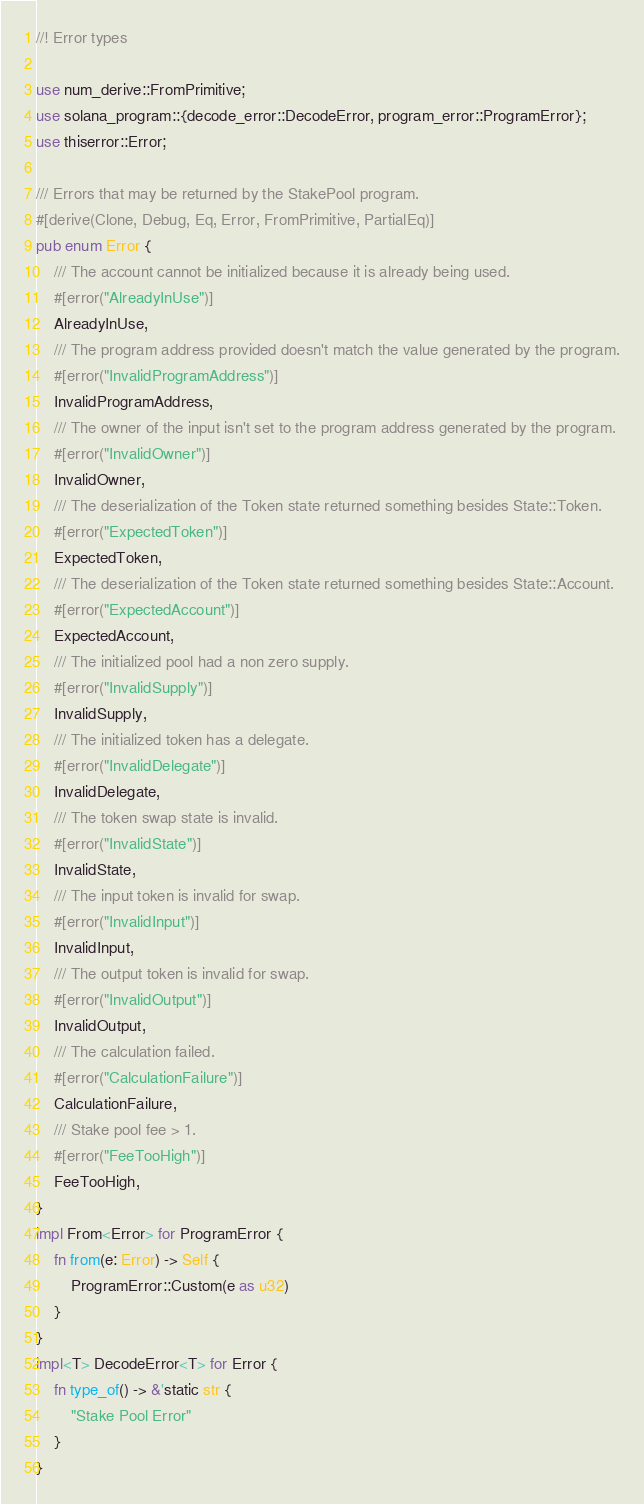<code> <loc_0><loc_0><loc_500><loc_500><_Rust_>//! Error types

use num_derive::FromPrimitive;
use solana_program::{decode_error::DecodeError, program_error::ProgramError};
use thiserror::Error;

/// Errors that may be returned by the StakePool program.
#[derive(Clone, Debug, Eq, Error, FromPrimitive, PartialEq)]
pub enum Error {
    /// The account cannot be initialized because it is already being used.
    #[error("AlreadyInUse")]
    AlreadyInUse,
    /// The program address provided doesn't match the value generated by the program.
    #[error("InvalidProgramAddress")]
    InvalidProgramAddress,
    /// The owner of the input isn't set to the program address generated by the program.
    #[error("InvalidOwner")]
    InvalidOwner,
    /// The deserialization of the Token state returned something besides State::Token.
    #[error("ExpectedToken")]
    ExpectedToken,
    /// The deserialization of the Token state returned something besides State::Account.
    #[error("ExpectedAccount")]
    ExpectedAccount,
    /// The initialized pool had a non zero supply.
    #[error("InvalidSupply")]
    InvalidSupply,
    /// The initialized token has a delegate.
    #[error("InvalidDelegate")]
    InvalidDelegate,
    /// The token swap state is invalid.
    #[error("InvalidState")]
    InvalidState,
    /// The input token is invalid for swap.
    #[error("InvalidInput")]
    InvalidInput,
    /// The output token is invalid for swap.
    #[error("InvalidOutput")]
    InvalidOutput,
    /// The calculation failed.
    #[error("CalculationFailure")]
    CalculationFailure,
    /// Stake pool fee > 1.
    #[error("FeeTooHigh")]
    FeeTooHigh,
}
impl From<Error> for ProgramError {
    fn from(e: Error) -> Self {
        ProgramError::Custom(e as u32)
    }
}
impl<T> DecodeError<T> for Error {
    fn type_of() -> &'static str {
        "Stake Pool Error"
    }
}
</code> 